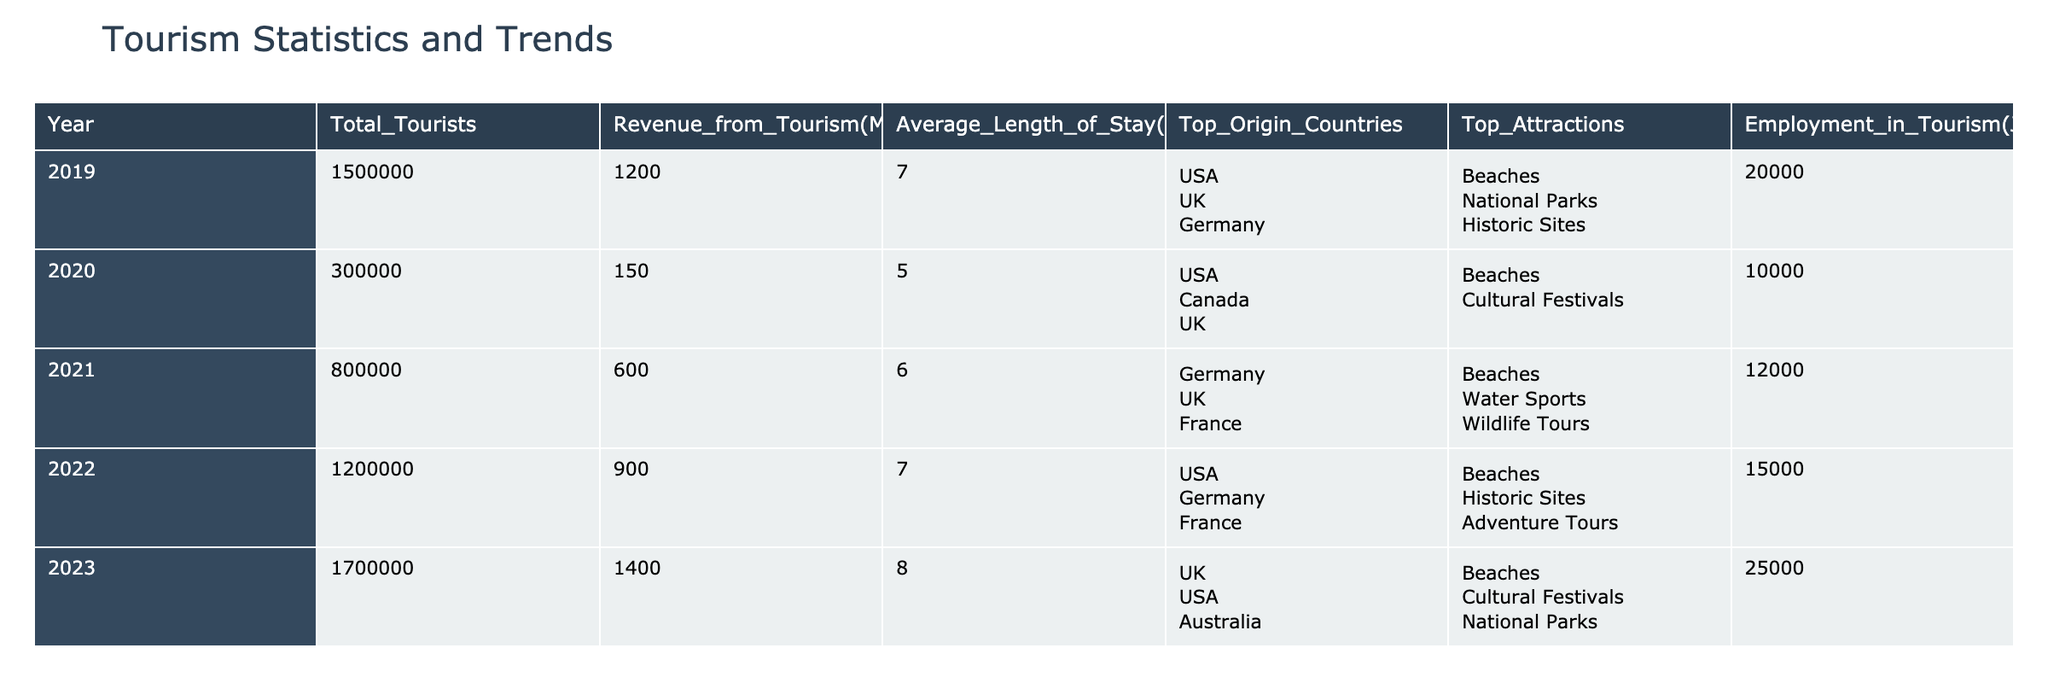What was the total number of tourists in 2022? The table shows that in 2022, the total number of tourists was listed as 1,200,000.
Answer: 1,200,000 Which year had the highest revenue from tourism? By looking at the revenue from tourism for each year, 2023 shows the highest figure at 1,400 million USD.
Answer: 2023 What was the average length of stay for tourists in 2020? The table states that in 2020, the average length of stay was 5 days.
Answer: 5 days How much did revenue from tourism increase from 2021 to 2022? The revenue from tourism in 2021 was 600 million USD and in 2022 it was 900 million USD. The increase is 900 - 600 = 300 million USD.
Answer: 300 million USD Did employment in tourism increase every year from 2019 to 2023? Checking the employment figures for each year shows: 20,000 (2019), 10,000 (2020), 12,000 (2021), 15,000 (2022), and 25,000 (2023). Since 2020 had a decrease, the statement is false.
Answer: No What is the average number of tourists over the 5 years? The total number of tourists over the years (1,500,000 + 300,000 + 800,000 + 1,200,000 + 1,700,000) is 5,500,000. Dividing this by 5 (the number of years) gives 5,500,000 / 5 = 1,100,000.
Answer: 1,100,000 Which top origin country was most consistent in the top 3 from 2019 to 2023? By analyzing the "Top Origin Countries" from each year, the USA appeared in 2019, 2020, 2022, and 2023, while Germany appeared in 2019, 2021, and 2022. The USA is the most consistent.
Answer: USA What were the top three attractions in 2021? The table lists the top attractions for 2021 as "Beaches", "Water Sports", and "Wildlife Tours".
Answer: Beaches, Water Sports, Wildlife Tours How many jobs were created in tourism from 2020 to 2023? The number of jobs in 2020 was 10,000 and increased to 25,000 in 2023. The increase is 25,000 - 10,000 = 15,000 jobs.
Answer: 15,000 jobs In which year was the average length of stay the longest? The average length of stay for each year shows the following: 7 (2019), 5 (2020), 6 (2021), 7 (2022), and 8 (2023). The longest stay was in 2023 at 8 days.
Answer: 2023 